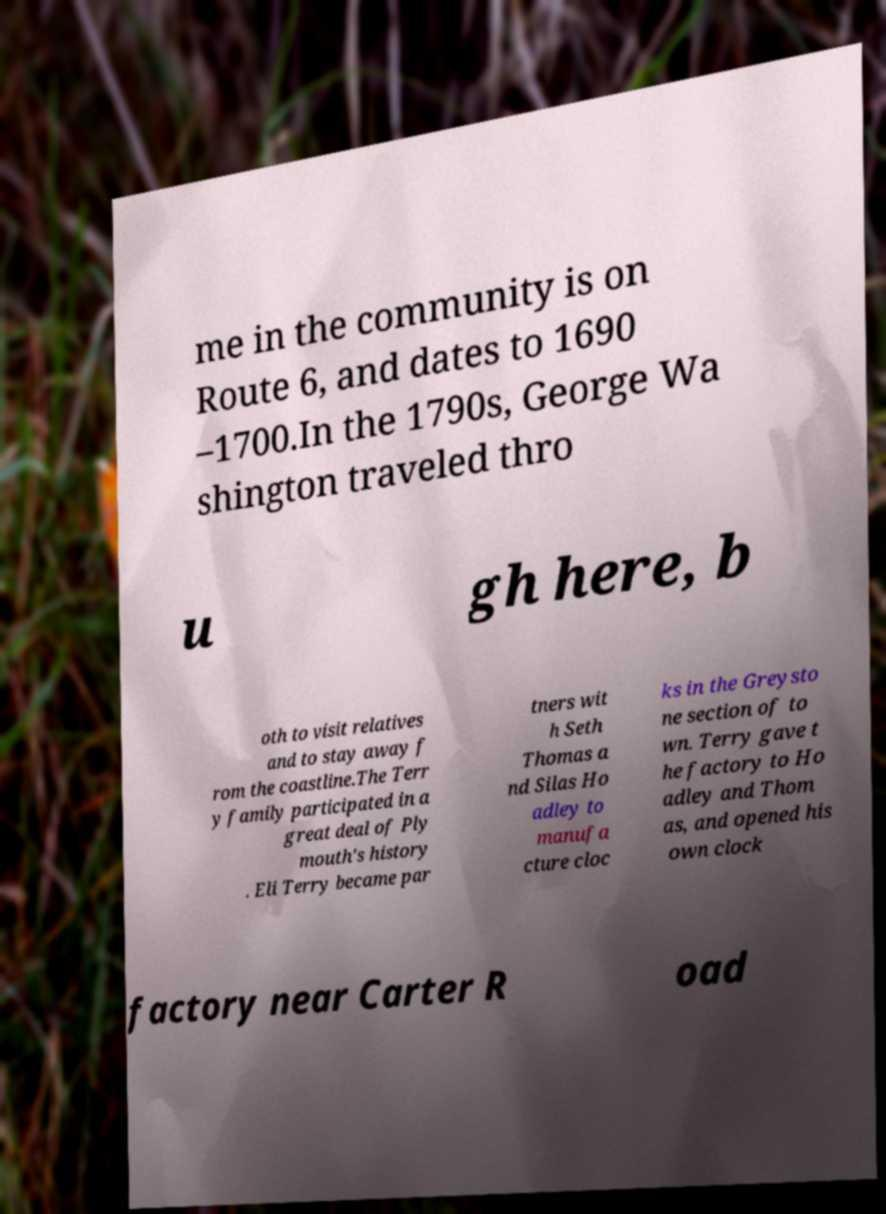Please read and relay the text visible in this image. What does it say? me in the community is on Route 6, and dates to 1690 –1700.In the 1790s, George Wa shington traveled thro u gh here, b oth to visit relatives and to stay away f rom the coastline.The Terr y family participated in a great deal of Ply mouth's history . Eli Terry became par tners wit h Seth Thomas a nd Silas Ho adley to manufa cture cloc ks in the Greysto ne section of to wn. Terry gave t he factory to Ho adley and Thom as, and opened his own clock factory near Carter R oad 